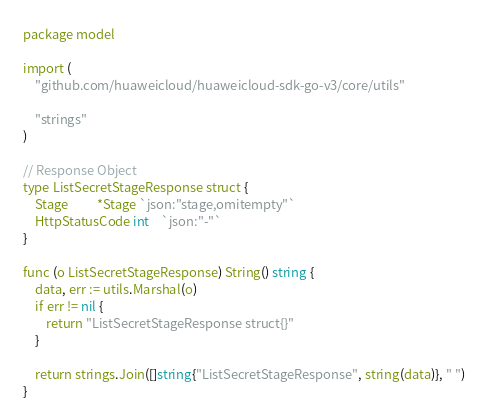<code> <loc_0><loc_0><loc_500><loc_500><_Go_>package model

import (
	"github.com/huaweicloud/huaweicloud-sdk-go-v3/core/utils"

	"strings"
)

// Response Object
type ListSecretStageResponse struct {
	Stage          *Stage `json:"stage,omitempty"`
	HttpStatusCode int    `json:"-"`
}

func (o ListSecretStageResponse) String() string {
	data, err := utils.Marshal(o)
	if err != nil {
		return "ListSecretStageResponse struct{}"
	}

	return strings.Join([]string{"ListSecretStageResponse", string(data)}, " ")
}
</code> 